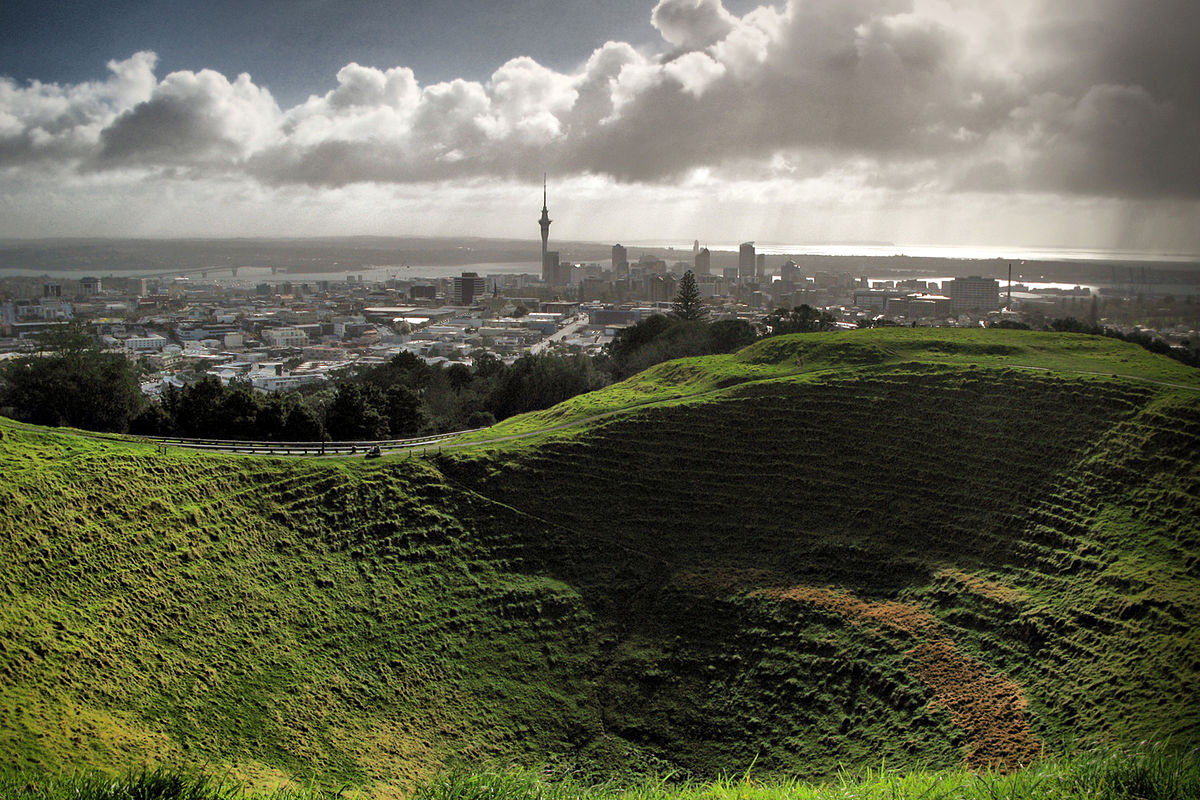How does the plant life in this crater compare to the city's green spaces? The plant life within Mt Eden Crater contrasts significantly with Auckland's urban green spaces. As a natural formation, the crater supports a range of native vegetation, thriving in a comparatively undisturbed setting. In contrast, the city's parks and green areas often feature landscaped gardens, exotic species, and manicured lawns designed for aesthetic appeal and recreational use. The wild, unkempt nature of the crater's flora provides a glimpse into New Zealand's native ecological heritage. 